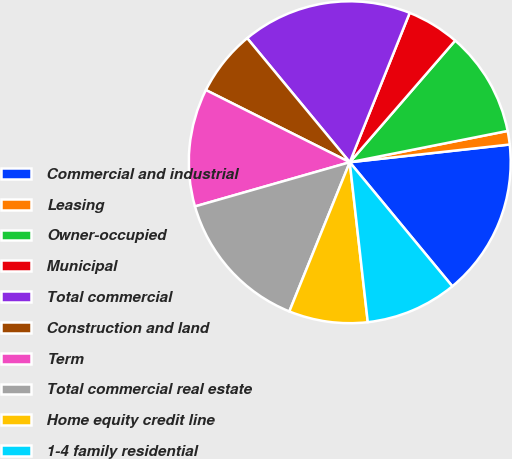<chart> <loc_0><loc_0><loc_500><loc_500><pie_chart><fcel>Commercial and industrial<fcel>Leasing<fcel>Owner-occupied<fcel>Municipal<fcel>Total commercial<fcel>Construction and land<fcel>Term<fcel>Total commercial real estate<fcel>Home equity credit line<fcel>1-4 family residential<nl><fcel>15.76%<fcel>1.36%<fcel>10.52%<fcel>5.29%<fcel>17.07%<fcel>6.6%<fcel>11.83%<fcel>14.45%<fcel>7.91%<fcel>9.21%<nl></chart> 